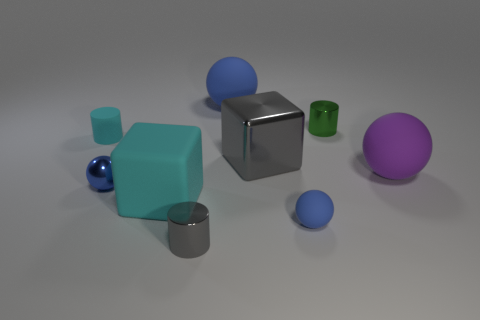Do the gray cylinder and the cyan cylinder have the same size?
Keep it short and to the point. Yes. The matte sphere that is to the right of the large blue ball and left of the purple object is what color?
Give a very brief answer. Blue. How many cyan cylinders have the same material as the small gray cylinder?
Your answer should be compact. 0. How many blue spheres are there?
Make the answer very short. 3. There is a gray metallic cylinder; is it the same size as the blue rubber sphere in front of the large gray object?
Your response must be concise. Yes. What material is the small sphere behind the cube that is in front of the large purple rubber object made of?
Ensure brevity in your answer.  Metal. What size is the object behind the green cylinder behind the gray thing in front of the small blue metallic thing?
Your answer should be very brief. Large. Does the big shiny thing have the same shape as the big object that is on the left side of the tiny gray thing?
Provide a succinct answer. Yes. What is the material of the large cyan cube?
Make the answer very short. Rubber. How many matte things are purple balls or small blue things?
Keep it short and to the point. 2. 